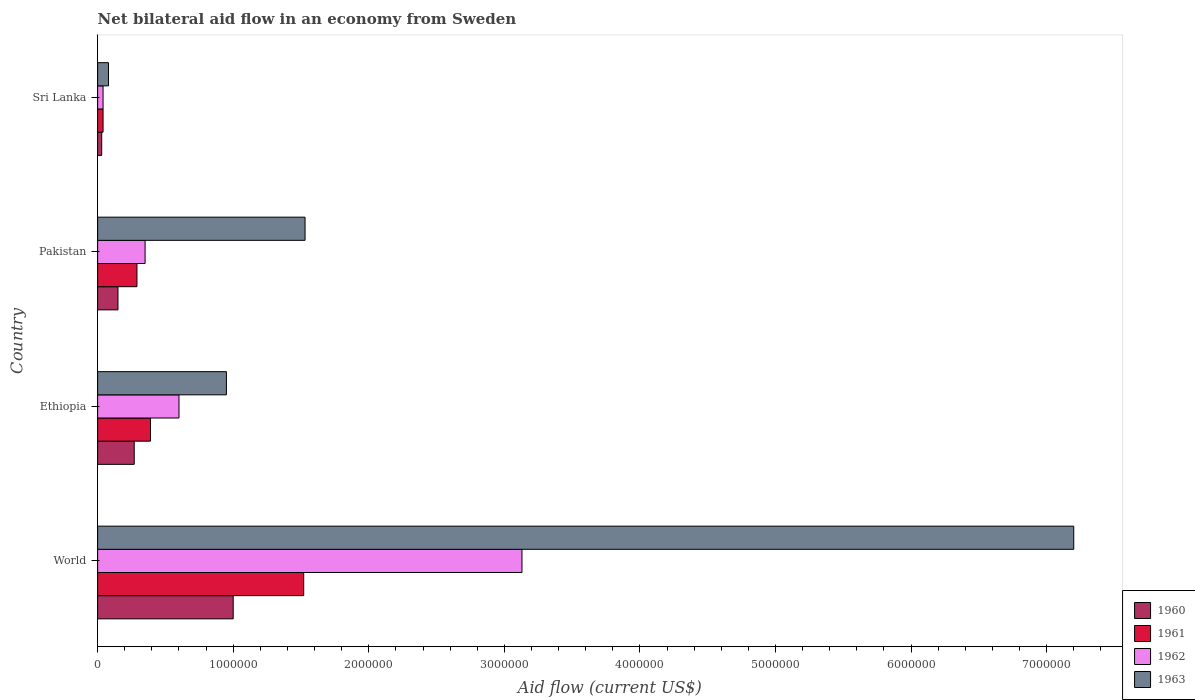How many groups of bars are there?
Your answer should be very brief. 4. Are the number of bars per tick equal to the number of legend labels?
Offer a very short reply. Yes. How many bars are there on the 3rd tick from the top?
Your answer should be compact. 4. What is the label of the 1st group of bars from the top?
Your response must be concise. Sri Lanka. Across all countries, what is the maximum net bilateral aid flow in 1962?
Offer a terse response. 3.13e+06. In which country was the net bilateral aid flow in 1962 minimum?
Offer a terse response. Sri Lanka. What is the total net bilateral aid flow in 1960 in the graph?
Your answer should be very brief. 1.45e+06. What is the difference between the net bilateral aid flow in 1963 in Sri Lanka and that in World?
Offer a very short reply. -7.12e+06. What is the difference between the net bilateral aid flow in 1960 in World and the net bilateral aid flow in 1963 in Pakistan?
Your answer should be compact. -5.30e+05. What is the average net bilateral aid flow in 1962 per country?
Your response must be concise. 1.03e+06. What is the difference between the net bilateral aid flow in 1961 and net bilateral aid flow in 1963 in Pakistan?
Make the answer very short. -1.24e+06. In how many countries, is the net bilateral aid flow in 1961 greater than 1600000 US$?
Your response must be concise. 0. What is the ratio of the net bilateral aid flow in 1961 in Sri Lanka to that in World?
Ensure brevity in your answer.  0.03. Is the net bilateral aid flow in 1961 in Ethiopia less than that in World?
Offer a terse response. Yes. Is the difference between the net bilateral aid flow in 1961 in Pakistan and Sri Lanka greater than the difference between the net bilateral aid flow in 1963 in Pakistan and Sri Lanka?
Keep it short and to the point. No. What is the difference between the highest and the second highest net bilateral aid flow in 1960?
Offer a very short reply. 7.30e+05. What is the difference between the highest and the lowest net bilateral aid flow in 1961?
Make the answer very short. 1.48e+06. Is the sum of the net bilateral aid flow in 1961 in Ethiopia and World greater than the maximum net bilateral aid flow in 1960 across all countries?
Provide a short and direct response. Yes. Is it the case that in every country, the sum of the net bilateral aid flow in 1961 and net bilateral aid flow in 1962 is greater than the sum of net bilateral aid flow in 1960 and net bilateral aid flow in 1963?
Your answer should be compact. No. What does the 4th bar from the bottom in World represents?
Ensure brevity in your answer.  1963. Is it the case that in every country, the sum of the net bilateral aid flow in 1963 and net bilateral aid flow in 1960 is greater than the net bilateral aid flow in 1962?
Provide a short and direct response. Yes. How many bars are there?
Give a very brief answer. 16. Are all the bars in the graph horizontal?
Offer a very short reply. Yes. What is the difference between two consecutive major ticks on the X-axis?
Your response must be concise. 1.00e+06. Are the values on the major ticks of X-axis written in scientific E-notation?
Give a very brief answer. No. Does the graph contain any zero values?
Your answer should be compact. No. How are the legend labels stacked?
Offer a terse response. Vertical. What is the title of the graph?
Your answer should be very brief. Net bilateral aid flow in an economy from Sweden. What is the label or title of the X-axis?
Your response must be concise. Aid flow (current US$). What is the label or title of the Y-axis?
Offer a terse response. Country. What is the Aid flow (current US$) of 1961 in World?
Your answer should be compact. 1.52e+06. What is the Aid flow (current US$) of 1962 in World?
Give a very brief answer. 3.13e+06. What is the Aid flow (current US$) in 1963 in World?
Your answer should be very brief. 7.20e+06. What is the Aid flow (current US$) in 1961 in Ethiopia?
Provide a short and direct response. 3.90e+05. What is the Aid flow (current US$) of 1962 in Ethiopia?
Your response must be concise. 6.00e+05. What is the Aid flow (current US$) in 1963 in Ethiopia?
Your response must be concise. 9.50e+05. What is the Aid flow (current US$) in 1960 in Pakistan?
Your response must be concise. 1.50e+05. What is the Aid flow (current US$) of 1961 in Pakistan?
Offer a very short reply. 2.90e+05. What is the Aid flow (current US$) of 1963 in Pakistan?
Make the answer very short. 1.53e+06. What is the Aid flow (current US$) in 1960 in Sri Lanka?
Your answer should be very brief. 3.00e+04. What is the Aid flow (current US$) in 1961 in Sri Lanka?
Provide a succinct answer. 4.00e+04. What is the Aid flow (current US$) of 1962 in Sri Lanka?
Give a very brief answer. 4.00e+04. Across all countries, what is the maximum Aid flow (current US$) of 1960?
Give a very brief answer. 1.00e+06. Across all countries, what is the maximum Aid flow (current US$) of 1961?
Your response must be concise. 1.52e+06. Across all countries, what is the maximum Aid flow (current US$) in 1962?
Offer a very short reply. 3.13e+06. Across all countries, what is the maximum Aid flow (current US$) of 1963?
Your response must be concise. 7.20e+06. What is the total Aid flow (current US$) of 1960 in the graph?
Ensure brevity in your answer.  1.45e+06. What is the total Aid flow (current US$) of 1961 in the graph?
Offer a terse response. 2.24e+06. What is the total Aid flow (current US$) in 1962 in the graph?
Keep it short and to the point. 4.12e+06. What is the total Aid flow (current US$) of 1963 in the graph?
Your answer should be very brief. 9.76e+06. What is the difference between the Aid flow (current US$) in 1960 in World and that in Ethiopia?
Give a very brief answer. 7.30e+05. What is the difference between the Aid flow (current US$) of 1961 in World and that in Ethiopia?
Provide a succinct answer. 1.13e+06. What is the difference between the Aid flow (current US$) in 1962 in World and that in Ethiopia?
Provide a short and direct response. 2.53e+06. What is the difference between the Aid flow (current US$) in 1963 in World and that in Ethiopia?
Your answer should be very brief. 6.25e+06. What is the difference between the Aid flow (current US$) in 1960 in World and that in Pakistan?
Your response must be concise. 8.50e+05. What is the difference between the Aid flow (current US$) of 1961 in World and that in Pakistan?
Your answer should be very brief. 1.23e+06. What is the difference between the Aid flow (current US$) in 1962 in World and that in Pakistan?
Your response must be concise. 2.78e+06. What is the difference between the Aid flow (current US$) in 1963 in World and that in Pakistan?
Keep it short and to the point. 5.67e+06. What is the difference between the Aid flow (current US$) in 1960 in World and that in Sri Lanka?
Your response must be concise. 9.70e+05. What is the difference between the Aid flow (current US$) of 1961 in World and that in Sri Lanka?
Give a very brief answer. 1.48e+06. What is the difference between the Aid flow (current US$) in 1962 in World and that in Sri Lanka?
Give a very brief answer. 3.09e+06. What is the difference between the Aid flow (current US$) in 1963 in World and that in Sri Lanka?
Ensure brevity in your answer.  7.12e+06. What is the difference between the Aid flow (current US$) in 1961 in Ethiopia and that in Pakistan?
Your answer should be very brief. 1.00e+05. What is the difference between the Aid flow (current US$) of 1963 in Ethiopia and that in Pakistan?
Offer a very short reply. -5.80e+05. What is the difference between the Aid flow (current US$) of 1960 in Ethiopia and that in Sri Lanka?
Offer a very short reply. 2.40e+05. What is the difference between the Aid flow (current US$) in 1962 in Ethiopia and that in Sri Lanka?
Ensure brevity in your answer.  5.60e+05. What is the difference between the Aid flow (current US$) in 1963 in Ethiopia and that in Sri Lanka?
Keep it short and to the point. 8.70e+05. What is the difference between the Aid flow (current US$) in 1960 in Pakistan and that in Sri Lanka?
Keep it short and to the point. 1.20e+05. What is the difference between the Aid flow (current US$) in 1961 in Pakistan and that in Sri Lanka?
Ensure brevity in your answer.  2.50e+05. What is the difference between the Aid flow (current US$) in 1963 in Pakistan and that in Sri Lanka?
Keep it short and to the point. 1.45e+06. What is the difference between the Aid flow (current US$) in 1961 in World and the Aid flow (current US$) in 1962 in Ethiopia?
Offer a terse response. 9.20e+05. What is the difference between the Aid flow (current US$) in 1961 in World and the Aid flow (current US$) in 1963 in Ethiopia?
Give a very brief answer. 5.70e+05. What is the difference between the Aid flow (current US$) in 1962 in World and the Aid flow (current US$) in 1963 in Ethiopia?
Provide a short and direct response. 2.18e+06. What is the difference between the Aid flow (current US$) of 1960 in World and the Aid flow (current US$) of 1961 in Pakistan?
Provide a short and direct response. 7.10e+05. What is the difference between the Aid flow (current US$) of 1960 in World and the Aid flow (current US$) of 1962 in Pakistan?
Your answer should be very brief. 6.50e+05. What is the difference between the Aid flow (current US$) of 1960 in World and the Aid flow (current US$) of 1963 in Pakistan?
Provide a short and direct response. -5.30e+05. What is the difference between the Aid flow (current US$) in 1961 in World and the Aid flow (current US$) in 1962 in Pakistan?
Offer a terse response. 1.17e+06. What is the difference between the Aid flow (current US$) of 1962 in World and the Aid flow (current US$) of 1963 in Pakistan?
Your answer should be very brief. 1.60e+06. What is the difference between the Aid flow (current US$) of 1960 in World and the Aid flow (current US$) of 1961 in Sri Lanka?
Your response must be concise. 9.60e+05. What is the difference between the Aid flow (current US$) in 1960 in World and the Aid flow (current US$) in 1962 in Sri Lanka?
Your response must be concise. 9.60e+05. What is the difference between the Aid flow (current US$) of 1960 in World and the Aid flow (current US$) of 1963 in Sri Lanka?
Your answer should be compact. 9.20e+05. What is the difference between the Aid flow (current US$) of 1961 in World and the Aid flow (current US$) of 1962 in Sri Lanka?
Ensure brevity in your answer.  1.48e+06. What is the difference between the Aid flow (current US$) of 1961 in World and the Aid flow (current US$) of 1963 in Sri Lanka?
Offer a terse response. 1.44e+06. What is the difference between the Aid flow (current US$) of 1962 in World and the Aid flow (current US$) of 1963 in Sri Lanka?
Your answer should be compact. 3.05e+06. What is the difference between the Aid flow (current US$) of 1960 in Ethiopia and the Aid flow (current US$) of 1962 in Pakistan?
Your answer should be very brief. -8.00e+04. What is the difference between the Aid flow (current US$) in 1960 in Ethiopia and the Aid flow (current US$) in 1963 in Pakistan?
Make the answer very short. -1.26e+06. What is the difference between the Aid flow (current US$) of 1961 in Ethiopia and the Aid flow (current US$) of 1963 in Pakistan?
Give a very brief answer. -1.14e+06. What is the difference between the Aid flow (current US$) in 1962 in Ethiopia and the Aid flow (current US$) in 1963 in Pakistan?
Your answer should be very brief. -9.30e+05. What is the difference between the Aid flow (current US$) in 1960 in Ethiopia and the Aid flow (current US$) in 1961 in Sri Lanka?
Provide a short and direct response. 2.30e+05. What is the difference between the Aid flow (current US$) of 1960 in Ethiopia and the Aid flow (current US$) of 1962 in Sri Lanka?
Make the answer very short. 2.30e+05. What is the difference between the Aid flow (current US$) in 1961 in Ethiopia and the Aid flow (current US$) in 1962 in Sri Lanka?
Provide a succinct answer. 3.50e+05. What is the difference between the Aid flow (current US$) of 1962 in Ethiopia and the Aid flow (current US$) of 1963 in Sri Lanka?
Make the answer very short. 5.20e+05. What is the difference between the Aid flow (current US$) in 1960 in Pakistan and the Aid flow (current US$) in 1962 in Sri Lanka?
Provide a succinct answer. 1.10e+05. What is the difference between the Aid flow (current US$) of 1961 in Pakistan and the Aid flow (current US$) of 1962 in Sri Lanka?
Ensure brevity in your answer.  2.50e+05. What is the difference between the Aid flow (current US$) in 1961 in Pakistan and the Aid flow (current US$) in 1963 in Sri Lanka?
Provide a short and direct response. 2.10e+05. What is the average Aid flow (current US$) of 1960 per country?
Offer a terse response. 3.62e+05. What is the average Aid flow (current US$) in 1961 per country?
Your answer should be very brief. 5.60e+05. What is the average Aid flow (current US$) of 1962 per country?
Your response must be concise. 1.03e+06. What is the average Aid flow (current US$) in 1963 per country?
Offer a terse response. 2.44e+06. What is the difference between the Aid flow (current US$) in 1960 and Aid flow (current US$) in 1961 in World?
Ensure brevity in your answer.  -5.20e+05. What is the difference between the Aid flow (current US$) in 1960 and Aid flow (current US$) in 1962 in World?
Offer a terse response. -2.13e+06. What is the difference between the Aid flow (current US$) in 1960 and Aid flow (current US$) in 1963 in World?
Keep it short and to the point. -6.20e+06. What is the difference between the Aid flow (current US$) of 1961 and Aid flow (current US$) of 1962 in World?
Give a very brief answer. -1.61e+06. What is the difference between the Aid flow (current US$) in 1961 and Aid flow (current US$) in 1963 in World?
Keep it short and to the point. -5.68e+06. What is the difference between the Aid flow (current US$) in 1962 and Aid flow (current US$) in 1963 in World?
Give a very brief answer. -4.07e+06. What is the difference between the Aid flow (current US$) in 1960 and Aid flow (current US$) in 1961 in Ethiopia?
Ensure brevity in your answer.  -1.20e+05. What is the difference between the Aid flow (current US$) of 1960 and Aid flow (current US$) of 1962 in Ethiopia?
Your answer should be very brief. -3.30e+05. What is the difference between the Aid flow (current US$) in 1960 and Aid flow (current US$) in 1963 in Ethiopia?
Your answer should be compact. -6.80e+05. What is the difference between the Aid flow (current US$) in 1961 and Aid flow (current US$) in 1963 in Ethiopia?
Offer a terse response. -5.60e+05. What is the difference between the Aid flow (current US$) in 1962 and Aid flow (current US$) in 1963 in Ethiopia?
Give a very brief answer. -3.50e+05. What is the difference between the Aid flow (current US$) in 1960 and Aid flow (current US$) in 1961 in Pakistan?
Provide a succinct answer. -1.40e+05. What is the difference between the Aid flow (current US$) in 1960 and Aid flow (current US$) in 1963 in Pakistan?
Give a very brief answer. -1.38e+06. What is the difference between the Aid flow (current US$) in 1961 and Aid flow (current US$) in 1963 in Pakistan?
Ensure brevity in your answer.  -1.24e+06. What is the difference between the Aid flow (current US$) in 1962 and Aid flow (current US$) in 1963 in Pakistan?
Provide a short and direct response. -1.18e+06. What is the difference between the Aid flow (current US$) of 1960 and Aid flow (current US$) of 1961 in Sri Lanka?
Keep it short and to the point. -10000. What is the difference between the Aid flow (current US$) in 1960 and Aid flow (current US$) in 1963 in Sri Lanka?
Offer a terse response. -5.00e+04. What is the difference between the Aid flow (current US$) of 1961 and Aid flow (current US$) of 1962 in Sri Lanka?
Give a very brief answer. 0. What is the difference between the Aid flow (current US$) in 1962 and Aid flow (current US$) in 1963 in Sri Lanka?
Keep it short and to the point. -4.00e+04. What is the ratio of the Aid flow (current US$) of 1960 in World to that in Ethiopia?
Make the answer very short. 3.7. What is the ratio of the Aid flow (current US$) in 1961 in World to that in Ethiopia?
Make the answer very short. 3.9. What is the ratio of the Aid flow (current US$) of 1962 in World to that in Ethiopia?
Make the answer very short. 5.22. What is the ratio of the Aid flow (current US$) of 1963 in World to that in Ethiopia?
Offer a very short reply. 7.58. What is the ratio of the Aid flow (current US$) in 1961 in World to that in Pakistan?
Provide a short and direct response. 5.24. What is the ratio of the Aid flow (current US$) in 1962 in World to that in Pakistan?
Keep it short and to the point. 8.94. What is the ratio of the Aid flow (current US$) of 1963 in World to that in Pakistan?
Your response must be concise. 4.71. What is the ratio of the Aid flow (current US$) of 1960 in World to that in Sri Lanka?
Ensure brevity in your answer.  33.33. What is the ratio of the Aid flow (current US$) of 1962 in World to that in Sri Lanka?
Keep it short and to the point. 78.25. What is the ratio of the Aid flow (current US$) of 1963 in World to that in Sri Lanka?
Keep it short and to the point. 90. What is the ratio of the Aid flow (current US$) of 1960 in Ethiopia to that in Pakistan?
Make the answer very short. 1.8. What is the ratio of the Aid flow (current US$) of 1961 in Ethiopia to that in Pakistan?
Keep it short and to the point. 1.34. What is the ratio of the Aid flow (current US$) of 1962 in Ethiopia to that in Pakistan?
Provide a short and direct response. 1.71. What is the ratio of the Aid flow (current US$) of 1963 in Ethiopia to that in Pakistan?
Provide a succinct answer. 0.62. What is the ratio of the Aid flow (current US$) of 1960 in Ethiopia to that in Sri Lanka?
Your answer should be compact. 9. What is the ratio of the Aid flow (current US$) in 1961 in Ethiopia to that in Sri Lanka?
Give a very brief answer. 9.75. What is the ratio of the Aid flow (current US$) in 1963 in Ethiopia to that in Sri Lanka?
Your response must be concise. 11.88. What is the ratio of the Aid flow (current US$) of 1961 in Pakistan to that in Sri Lanka?
Ensure brevity in your answer.  7.25. What is the ratio of the Aid flow (current US$) in 1962 in Pakistan to that in Sri Lanka?
Offer a terse response. 8.75. What is the ratio of the Aid flow (current US$) in 1963 in Pakistan to that in Sri Lanka?
Your answer should be compact. 19.12. What is the difference between the highest and the second highest Aid flow (current US$) of 1960?
Offer a very short reply. 7.30e+05. What is the difference between the highest and the second highest Aid flow (current US$) of 1961?
Make the answer very short. 1.13e+06. What is the difference between the highest and the second highest Aid flow (current US$) of 1962?
Offer a very short reply. 2.53e+06. What is the difference between the highest and the second highest Aid flow (current US$) of 1963?
Give a very brief answer. 5.67e+06. What is the difference between the highest and the lowest Aid flow (current US$) of 1960?
Provide a succinct answer. 9.70e+05. What is the difference between the highest and the lowest Aid flow (current US$) of 1961?
Offer a terse response. 1.48e+06. What is the difference between the highest and the lowest Aid flow (current US$) in 1962?
Provide a short and direct response. 3.09e+06. What is the difference between the highest and the lowest Aid flow (current US$) in 1963?
Provide a short and direct response. 7.12e+06. 